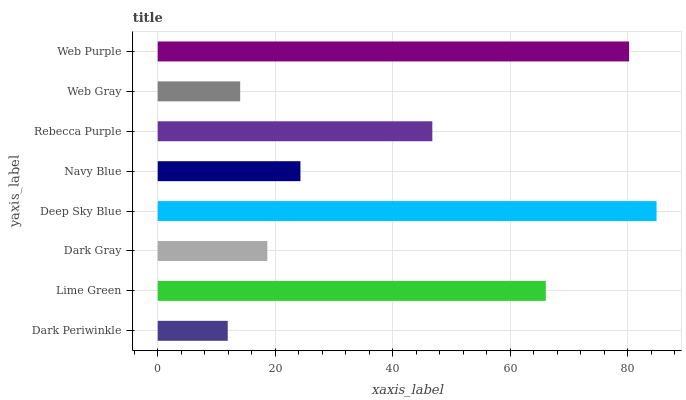Is Dark Periwinkle the minimum?
Answer yes or no. Yes. Is Deep Sky Blue the maximum?
Answer yes or no. Yes. Is Lime Green the minimum?
Answer yes or no. No. Is Lime Green the maximum?
Answer yes or no. No. Is Lime Green greater than Dark Periwinkle?
Answer yes or no. Yes. Is Dark Periwinkle less than Lime Green?
Answer yes or no. Yes. Is Dark Periwinkle greater than Lime Green?
Answer yes or no. No. Is Lime Green less than Dark Periwinkle?
Answer yes or no. No. Is Rebecca Purple the high median?
Answer yes or no. Yes. Is Navy Blue the low median?
Answer yes or no. Yes. Is Web Purple the high median?
Answer yes or no. No. Is Dark Gray the low median?
Answer yes or no. No. 